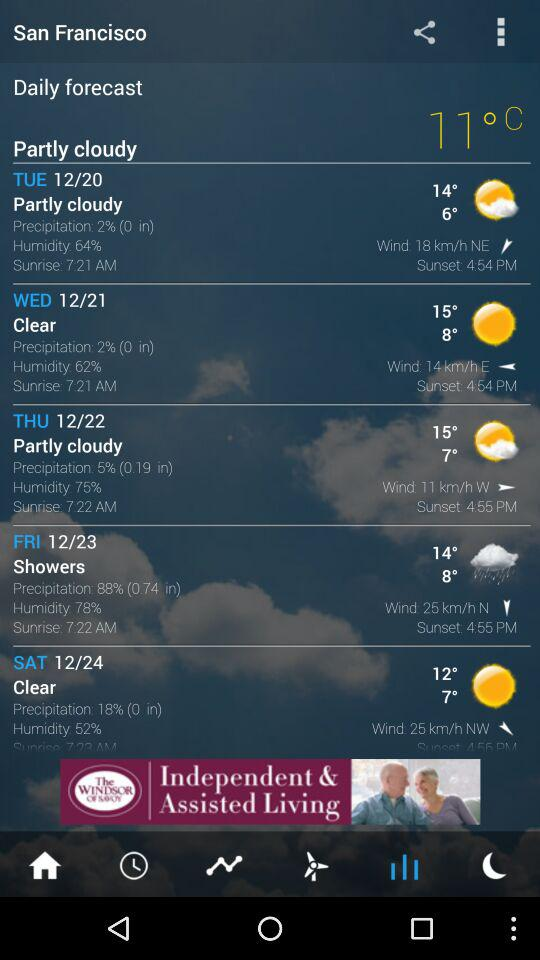What is the wind speed on Saturday? The speed is 25 km/h. 